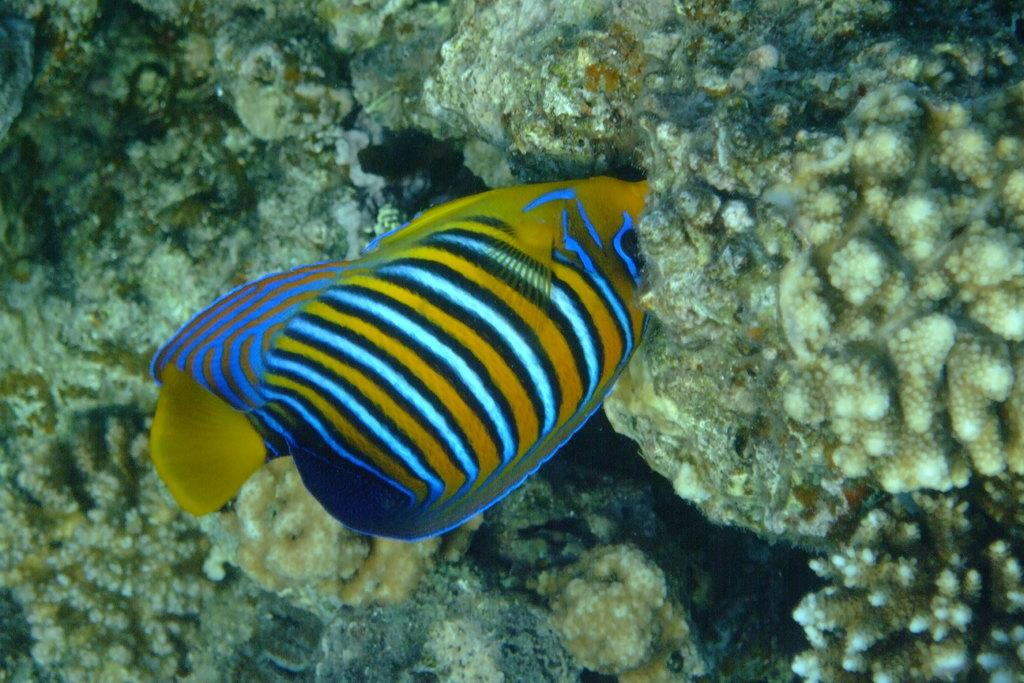What is the setting of the image? The picture is taken in water. What can be seen in the center of the image? There is a fish in the center of the image. What type of underwater environment is visible in the image? There are coral reefs in the image. What type of attraction is the fish visiting in the image? There is no indication in the image that the fish is visiting an attraction. --- 